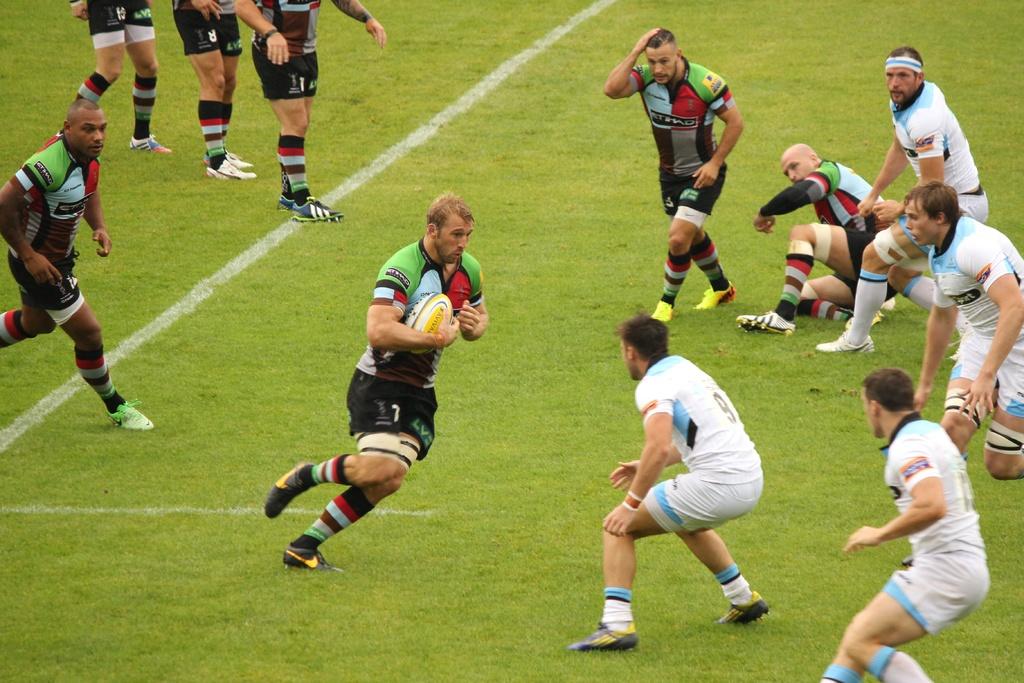What number is one of the players here?
Your answer should be compact. 9. 